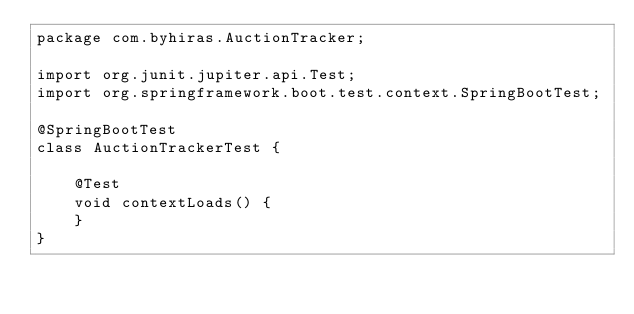Convert code to text. <code><loc_0><loc_0><loc_500><loc_500><_Java_>package com.byhiras.AuctionTracker;

import org.junit.jupiter.api.Test;
import org.springframework.boot.test.context.SpringBootTest;

@SpringBootTest
class AuctionTrackerTest {

	@Test
	void contextLoads() {
	}
}
</code> 